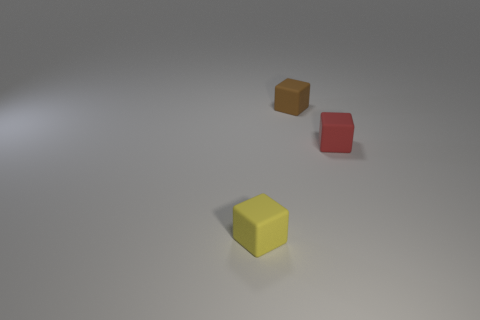Add 3 tiny yellow rubber objects. How many objects exist? 6 Subtract 1 brown blocks. How many objects are left? 2 Subtract all brown cylinders. Subtract all yellow rubber objects. How many objects are left? 2 Add 3 small brown cubes. How many small brown cubes are left? 4 Add 3 tiny rubber cubes. How many tiny rubber cubes exist? 6 